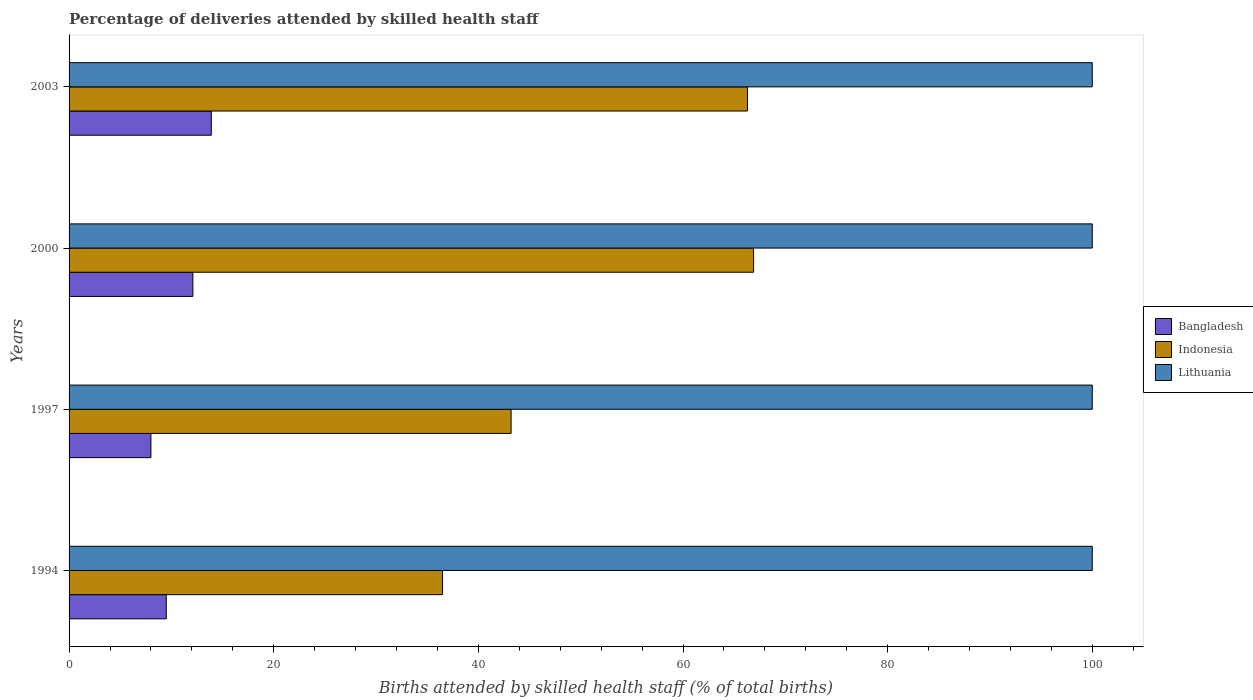How many different coloured bars are there?
Ensure brevity in your answer.  3. How many groups of bars are there?
Make the answer very short. 4. Are the number of bars on each tick of the Y-axis equal?
Keep it short and to the point. Yes. In how many cases, is the number of bars for a given year not equal to the number of legend labels?
Your answer should be compact. 0. What is the percentage of births attended by skilled health staff in Indonesia in 2003?
Your answer should be compact. 66.3. Across all years, what is the maximum percentage of births attended by skilled health staff in Indonesia?
Your answer should be compact. 66.9. Across all years, what is the minimum percentage of births attended by skilled health staff in Lithuania?
Keep it short and to the point. 100. In which year was the percentage of births attended by skilled health staff in Lithuania minimum?
Your answer should be very brief. 1994. What is the total percentage of births attended by skilled health staff in Indonesia in the graph?
Ensure brevity in your answer.  212.9. What is the difference between the percentage of births attended by skilled health staff in Indonesia in 2000 and the percentage of births attended by skilled health staff in Bangladesh in 2003?
Offer a very short reply. 53. What is the average percentage of births attended by skilled health staff in Lithuania per year?
Provide a short and direct response. 100. In the year 2000, what is the difference between the percentage of births attended by skilled health staff in Lithuania and percentage of births attended by skilled health staff in Bangladesh?
Your answer should be very brief. 87.9. In how many years, is the percentage of births attended by skilled health staff in Lithuania greater than 32 %?
Your response must be concise. 4. What is the ratio of the percentage of births attended by skilled health staff in Lithuania in 1997 to that in 2000?
Keep it short and to the point. 1. What is the difference between the highest and the second highest percentage of births attended by skilled health staff in Indonesia?
Your answer should be compact. 0.6. What is the difference between the highest and the lowest percentage of births attended by skilled health staff in Bangladesh?
Make the answer very short. 5.9. In how many years, is the percentage of births attended by skilled health staff in Lithuania greater than the average percentage of births attended by skilled health staff in Lithuania taken over all years?
Offer a very short reply. 0. Is the sum of the percentage of births attended by skilled health staff in Bangladesh in 1994 and 1997 greater than the maximum percentage of births attended by skilled health staff in Indonesia across all years?
Offer a terse response. No. Is it the case that in every year, the sum of the percentage of births attended by skilled health staff in Bangladesh and percentage of births attended by skilled health staff in Indonesia is greater than the percentage of births attended by skilled health staff in Lithuania?
Your answer should be compact. No. How many years are there in the graph?
Give a very brief answer. 4. Are the values on the major ticks of X-axis written in scientific E-notation?
Your response must be concise. No. How are the legend labels stacked?
Give a very brief answer. Vertical. What is the title of the graph?
Keep it short and to the point. Percentage of deliveries attended by skilled health staff. Does "Montenegro" appear as one of the legend labels in the graph?
Offer a terse response. No. What is the label or title of the X-axis?
Provide a short and direct response. Births attended by skilled health staff (% of total births). What is the label or title of the Y-axis?
Provide a succinct answer. Years. What is the Births attended by skilled health staff (% of total births) of Bangladesh in 1994?
Your answer should be compact. 9.5. What is the Births attended by skilled health staff (% of total births) in Indonesia in 1994?
Your answer should be very brief. 36.5. What is the Births attended by skilled health staff (% of total births) of Lithuania in 1994?
Your response must be concise. 100. What is the Births attended by skilled health staff (% of total births) of Indonesia in 1997?
Make the answer very short. 43.2. What is the Births attended by skilled health staff (% of total births) in Lithuania in 1997?
Provide a succinct answer. 100. What is the Births attended by skilled health staff (% of total births) of Indonesia in 2000?
Your response must be concise. 66.9. What is the Births attended by skilled health staff (% of total births) of Indonesia in 2003?
Ensure brevity in your answer.  66.3. What is the Births attended by skilled health staff (% of total births) of Lithuania in 2003?
Make the answer very short. 100. Across all years, what is the maximum Births attended by skilled health staff (% of total births) of Indonesia?
Make the answer very short. 66.9. Across all years, what is the minimum Births attended by skilled health staff (% of total births) in Indonesia?
Make the answer very short. 36.5. What is the total Births attended by skilled health staff (% of total births) of Bangladesh in the graph?
Your answer should be very brief. 43.5. What is the total Births attended by skilled health staff (% of total births) in Indonesia in the graph?
Make the answer very short. 212.9. What is the total Births attended by skilled health staff (% of total births) in Lithuania in the graph?
Ensure brevity in your answer.  400. What is the difference between the Births attended by skilled health staff (% of total births) in Bangladesh in 1994 and that in 1997?
Give a very brief answer. 1.5. What is the difference between the Births attended by skilled health staff (% of total births) in Indonesia in 1994 and that in 1997?
Ensure brevity in your answer.  -6.7. What is the difference between the Births attended by skilled health staff (% of total births) of Lithuania in 1994 and that in 1997?
Your answer should be very brief. 0. What is the difference between the Births attended by skilled health staff (% of total births) of Bangladesh in 1994 and that in 2000?
Keep it short and to the point. -2.6. What is the difference between the Births attended by skilled health staff (% of total births) of Indonesia in 1994 and that in 2000?
Ensure brevity in your answer.  -30.4. What is the difference between the Births attended by skilled health staff (% of total births) of Indonesia in 1994 and that in 2003?
Your answer should be compact. -29.8. What is the difference between the Births attended by skilled health staff (% of total births) of Lithuania in 1994 and that in 2003?
Ensure brevity in your answer.  0. What is the difference between the Births attended by skilled health staff (% of total births) of Bangladesh in 1997 and that in 2000?
Give a very brief answer. -4.1. What is the difference between the Births attended by skilled health staff (% of total births) in Indonesia in 1997 and that in 2000?
Give a very brief answer. -23.7. What is the difference between the Births attended by skilled health staff (% of total births) of Lithuania in 1997 and that in 2000?
Give a very brief answer. 0. What is the difference between the Births attended by skilled health staff (% of total births) in Bangladesh in 1997 and that in 2003?
Ensure brevity in your answer.  -5.9. What is the difference between the Births attended by skilled health staff (% of total births) in Indonesia in 1997 and that in 2003?
Keep it short and to the point. -23.1. What is the difference between the Births attended by skilled health staff (% of total births) of Lithuania in 1997 and that in 2003?
Provide a short and direct response. 0. What is the difference between the Births attended by skilled health staff (% of total births) of Indonesia in 2000 and that in 2003?
Offer a very short reply. 0.6. What is the difference between the Births attended by skilled health staff (% of total births) of Bangladesh in 1994 and the Births attended by skilled health staff (% of total births) of Indonesia in 1997?
Your answer should be compact. -33.7. What is the difference between the Births attended by skilled health staff (% of total births) in Bangladesh in 1994 and the Births attended by skilled health staff (% of total births) in Lithuania in 1997?
Make the answer very short. -90.5. What is the difference between the Births attended by skilled health staff (% of total births) in Indonesia in 1994 and the Births attended by skilled health staff (% of total births) in Lithuania in 1997?
Your response must be concise. -63.5. What is the difference between the Births attended by skilled health staff (% of total births) of Bangladesh in 1994 and the Births attended by skilled health staff (% of total births) of Indonesia in 2000?
Your answer should be compact. -57.4. What is the difference between the Births attended by skilled health staff (% of total births) of Bangladesh in 1994 and the Births attended by skilled health staff (% of total births) of Lithuania in 2000?
Keep it short and to the point. -90.5. What is the difference between the Births attended by skilled health staff (% of total births) in Indonesia in 1994 and the Births attended by skilled health staff (% of total births) in Lithuania in 2000?
Offer a very short reply. -63.5. What is the difference between the Births attended by skilled health staff (% of total births) of Bangladesh in 1994 and the Births attended by skilled health staff (% of total births) of Indonesia in 2003?
Provide a succinct answer. -56.8. What is the difference between the Births attended by skilled health staff (% of total births) in Bangladesh in 1994 and the Births attended by skilled health staff (% of total births) in Lithuania in 2003?
Keep it short and to the point. -90.5. What is the difference between the Births attended by skilled health staff (% of total births) of Indonesia in 1994 and the Births attended by skilled health staff (% of total births) of Lithuania in 2003?
Your answer should be compact. -63.5. What is the difference between the Births attended by skilled health staff (% of total births) of Bangladesh in 1997 and the Births attended by skilled health staff (% of total births) of Indonesia in 2000?
Give a very brief answer. -58.9. What is the difference between the Births attended by skilled health staff (% of total births) of Bangladesh in 1997 and the Births attended by skilled health staff (% of total births) of Lithuania in 2000?
Offer a very short reply. -92. What is the difference between the Births attended by skilled health staff (% of total births) in Indonesia in 1997 and the Births attended by skilled health staff (% of total births) in Lithuania in 2000?
Provide a short and direct response. -56.8. What is the difference between the Births attended by skilled health staff (% of total births) in Bangladesh in 1997 and the Births attended by skilled health staff (% of total births) in Indonesia in 2003?
Ensure brevity in your answer.  -58.3. What is the difference between the Births attended by skilled health staff (% of total births) of Bangladesh in 1997 and the Births attended by skilled health staff (% of total births) of Lithuania in 2003?
Keep it short and to the point. -92. What is the difference between the Births attended by skilled health staff (% of total births) of Indonesia in 1997 and the Births attended by skilled health staff (% of total births) of Lithuania in 2003?
Your answer should be compact. -56.8. What is the difference between the Births attended by skilled health staff (% of total births) in Bangladesh in 2000 and the Births attended by skilled health staff (% of total births) in Indonesia in 2003?
Give a very brief answer. -54.2. What is the difference between the Births attended by skilled health staff (% of total births) in Bangladesh in 2000 and the Births attended by skilled health staff (% of total births) in Lithuania in 2003?
Ensure brevity in your answer.  -87.9. What is the difference between the Births attended by skilled health staff (% of total births) in Indonesia in 2000 and the Births attended by skilled health staff (% of total births) in Lithuania in 2003?
Your response must be concise. -33.1. What is the average Births attended by skilled health staff (% of total births) in Bangladesh per year?
Offer a very short reply. 10.88. What is the average Births attended by skilled health staff (% of total births) of Indonesia per year?
Your response must be concise. 53.23. What is the average Births attended by skilled health staff (% of total births) of Lithuania per year?
Your response must be concise. 100. In the year 1994, what is the difference between the Births attended by skilled health staff (% of total births) in Bangladesh and Births attended by skilled health staff (% of total births) in Lithuania?
Your answer should be very brief. -90.5. In the year 1994, what is the difference between the Births attended by skilled health staff (% of total births) in Indonesia and Births attended by skilled health staff (% of total births) in Lithuania?
Provide a succinct answer. -63.5. In the year 1997, what is the difference between the Births attended by skilled health staff (% of total births) of Bangladesh and Births attended by skilled health staff (% of total births) of Indonesia?
Keep it short and to the point. -35.2. In the year 1997, what is the difference between the Births attended by skilled health staff (% of total births) in Bangladesh and Births attended by skilled health staff (% of total births) in Lithuania?
Your answer should be compact. -92. In the year 1997, what is the difference between the Births attended by skilled health staff (% of total births) in Indonesia and Births attended by skilled health staff (% of total births) in Lithuania?
Provide a short and direct response. -56.8. In the year 2000, what is the difference between the Births attended by skilled health staff (% of total births) in Bangladesh and Births attended by skilled health staff (% of total births) in Indonesia?
Your answer should be compact. -54.8. In the year 2000, what is the difference between the Births attended by skilled health staff (% of total births) of Bangladesh and Births attended by skilled health staff (% of total births) of Lithuania?
Provide a succinct answer. -87.9. In the year 2000, what is the difference between the Births attended by skilled health staff (% of total births) in Indonesia and Births attended by skilled health staff (% of total births) in Lithuania?
Provide a succinct answer. -33.1. In the year 2003, what is the difference between the Births attended by skilled health staff (% of total births) of Bangladesh and Births attended by skilled health staff (% of total births) of Indonesia?
Give a very brief answer. -52.4. In the year 2003, what is the difference between the Births attended by skilled health staff (% of total births) in Bangladesh and Births attended by skilled health staff (% of total births) in Lithuania?
Give a very brief answer. -86.1. In the year 2003, what is the difference between the Births attended by skilled health staff (% of total births) in Indonesia and Births attended by skilled health staff (% of total births) in Lithuania?
Give a very brief answer. -33.7. What is the ratio of the Births attended by skilled health staff (% of total births) of Bangladesh in 1994 to that in 1997?
Provide a succinct answer. 1.19. What is the ratio of the Births attended by skilled health staff (% of total births) in Indonesia in 1994 to that in 1997?
Provide a short and direct response. 0.84. What is the ratio of the Births attended by skilled health staff (% of total births) in Lithuania in 1994 to that in 1997?
Provide a succinct answer. 1. What is the ratio of the Births attended by skilled health staff (% of total births) in Bangladesh in 1994 to that in 2000?
Give a very brief answer. 0.79. What is the ratio of the Births attended by skilled health staff (% of total births) of Indonesia in 1994 to that in 2000?
Your answer should be very brief. 0.55. What is the ratio of the Births attended by skilled health staff (% of total births) in Bangladesh in 1994 to that in 2003?
Keep it short and to the point. 0.68. What is the ratio of the Births attended by skilled health staff (% of total births) of Indonesia in 1994 to that in 2003?
Offer a terse response. 0.55. What is the ratio of the Births attended by skilled health staff (% of total births) in Bangladesh in 1997 to that in 2000?
Your answer should be very brief. 0.66. What is the ratio of the Births attended by skilled health staff (% of total births) in Indonesia in 1997 to that in 2000?
Give a very brief answer. 0.65. What is the ratio of the Births attended by skilled health staff (% of total births) in Lithuania in 1997 to that in 2000?
Make the answer very short. 1. What is the ratio of the Births attended by skilled health staff (% of total births) in Bangladesh in 1997 to that in 2003?
Give a very brief answer. 0.58. What is the ratio of the Births attended by skilled health staff (% of total births) of Indonesia in 1997 to that in 2003?
Provide a succinct answer. 0.65. What is the ratio of the Births attended by skilled health staff (% of total births) of Bangladesh in 2000 to that in 2003?
Keep it short and to the point. 0.87. What is the difference between the highest and the lowest Births attended by skilled health staff (% of total births) of Bangladesh?
Give a very brief answer. 5.9. What is the difference between the highest and the lowest Births attended by skilled health staff (% of total births) of Indonesia?
Your answer should be compact. 30.4. 